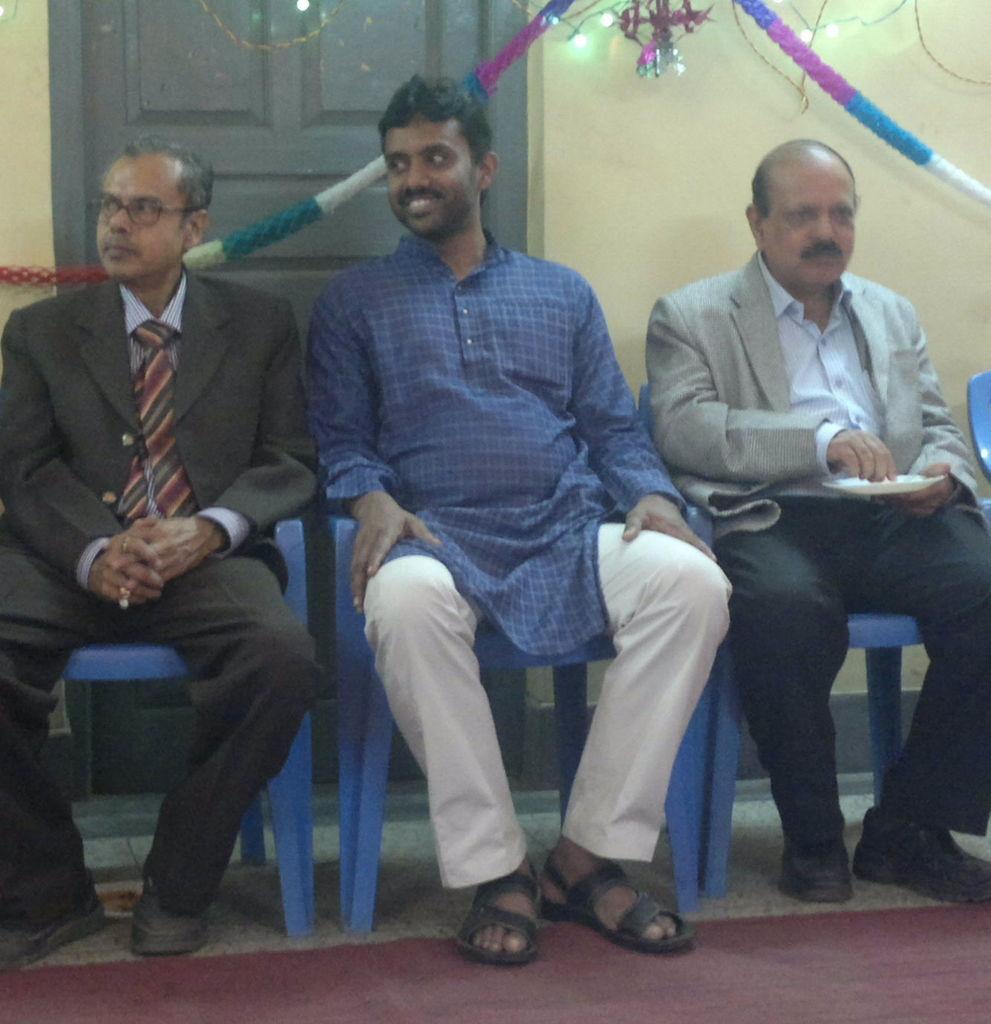Could you give a brief overview of what you see in this image? In this image, there are a few people sitting on chairs. We can see the ground with a red colored object. We can see the wall with a door. We can also see some ribbons, lights and a decorative object. 